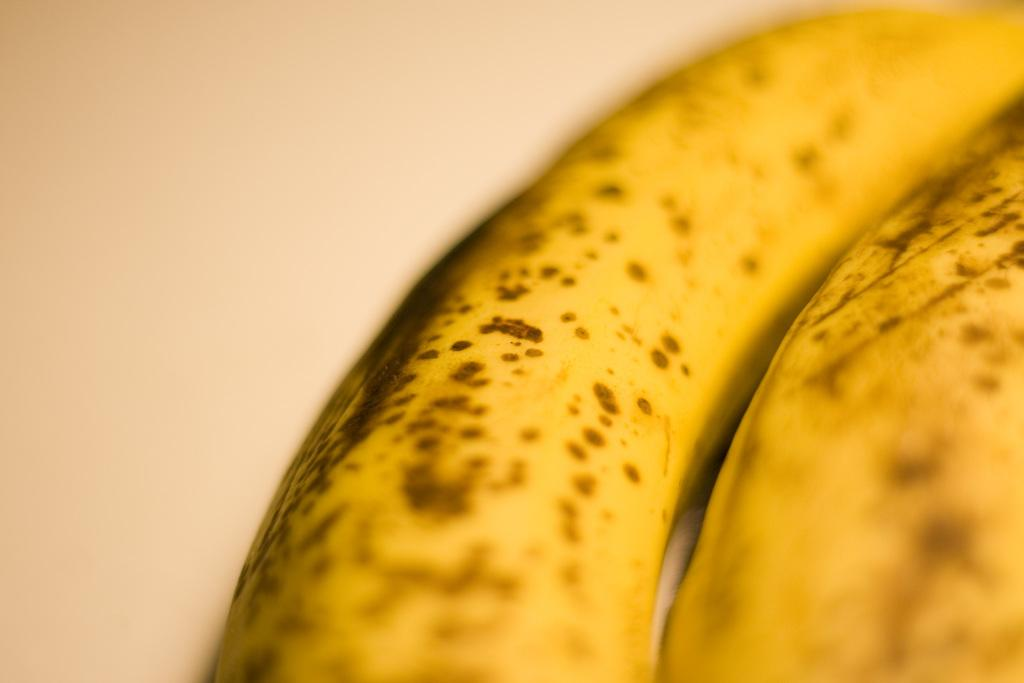What type of fruit is present in the image? There are two yellow bananas in the image. Can you describe the quality of the image? The image is slightly blurry. What type of suit is the daughter wearing in the image? There is no daughter or suit present in the image; it only features two yellow bananas. 